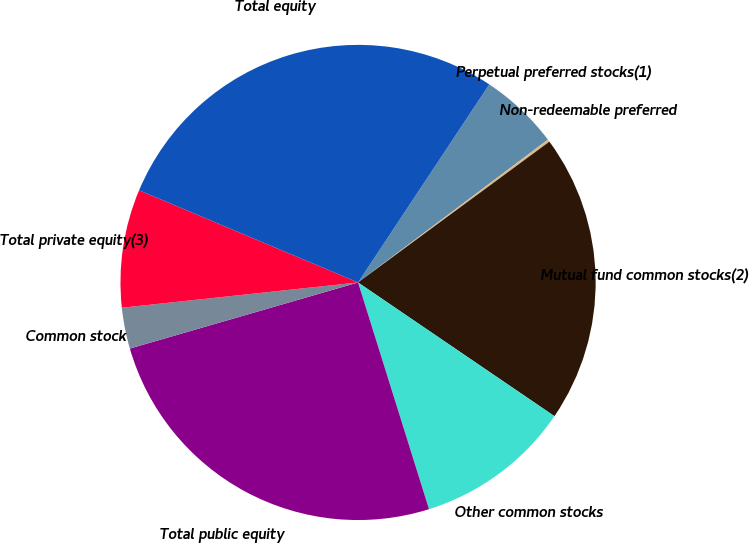<chart> <loc_0><loc_0><loc_500><loc_500><pie_chart><fcel>Perpetual preferred stocks(1)<fcel>Non-redeemable preferred<fcel>Mutual fund common stocks(2)<fcel>Other common stocks<fcel>Total public equity<fcel>Common stock<fcel>Total private equity(3)<fcel>Total equity<nl><fcel>5.42%<fcel>0.17%<fcel>19.61%<fcel>10.66%<fcel>25.34%<fcel>2.79%<fcel>8.04%<fcel>27.97%<nl></chart> 